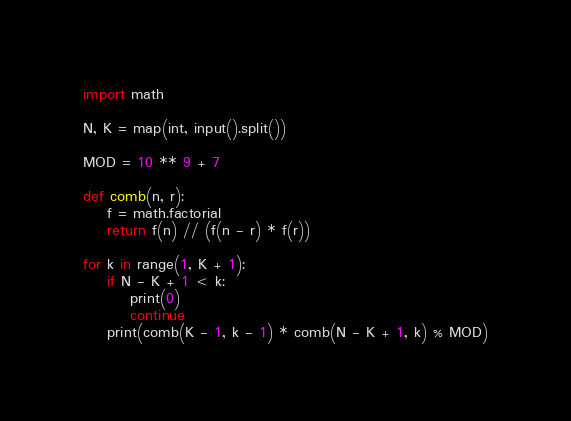<code> <loc_0><loc_0><loc_500><loc_500><_Python_>import math

N, K = map(int, input().split())

MOD = 10 ** 9 + 7

def comb(n, r):
	f = math.factorial
	return f(n) // (f(n - r) * f(r))

for k in range(1, K + 1):
	if N - K + 1 < k:
		print(0)
		continue
	print(comb(K - 1, k - 1) * comb(N - K + 1, k) % MOD)
</code> 